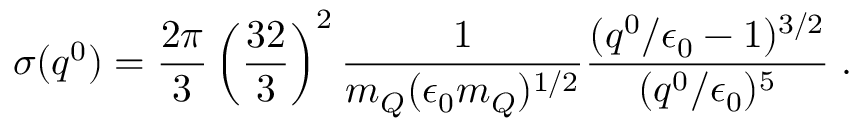Convert formula to latex. <formula><loc_0><loc_0><loc_500><loc_500>\sigma ( q ^ { 0 } ) = \frac { 2 \pi } { 3 } \left ( \frac { 3 2 } { 3 } \right ) ^ { 2 } \frac { 1 } { m _ { Q } ( \epsilon _ { 0 } m _ { Q } ) ^ { 1 / 2 } } \frac { ( q ^ { 0 } / \epsilon _ { 0 } - 1 ) ^ { 3 / 2 } } { ( q ^ { 0 } / \epsilon _ { 0 } ) ^ { 5 } } \, .</formula> 